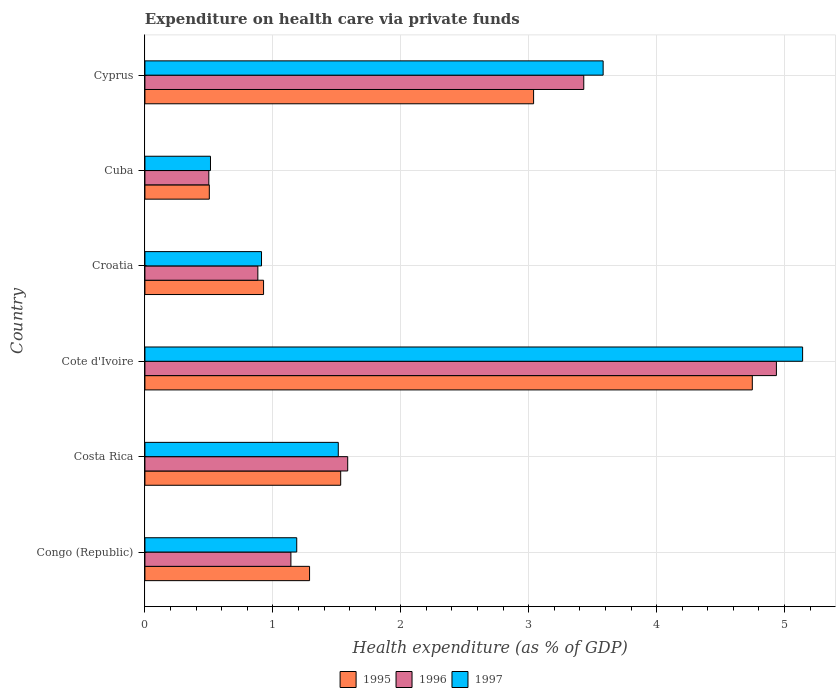How many different coloured bars are there?
Your answer should be very brief. 3. How many groups of bars are there?
Keep it short and to the point. 6. Are the number of bars per tick equal to the number of legend labels?
Your answer should be very brief. Yes. How many bars are there on the 6th tick from the top?
Your response must be concise. 3. What is the label of the 3rd group of bars from the top?
Your answer should be compact. Croatia. What is the expenditure made on health care in 1997 in Croatia?
Offer a terse response. 0.91. Across all countries, what is the maximum expenditure made on health care in 1995?
Your answer should be compact. 4.75. Across all countries, what is the minimum expenditure made on health care in 1996?
Give a very brief answer. 0.5. In which country was the expenditure made on health care in 1996 maximum?
Make the answer very short. Cote d'Ivoire. In which country was the expenditure made on health care in 1997 minimum?
Provide a succinct answer. Cuba. What is the total expenditure made on health care in 1997 in the graph?
Your answer should be very brief. 12.85. What is the difference between the expenditure made on health care in 1996 in Costa Rica and that in Croatia?
Provide a short and direct response. 0.7. What is the difference between the expenditure made on health care in 1997 in Croatia and the expenditure made on health care in 1996 in Congo (Republic)?
Make the answer very short. -0.23. What is the average expenditure made on health care in 1997 per country?
Your response must be concise. 2.14. What is the difference between the expenditure made on health care in 1996 and expenditure made on health care in 1997 in Congo (Republic)?
Your response must be concise. -0.05. In how many countries, is the expenditure made on health care in 1997 greater than 4 %?
Offer a very short reply. 1. What is the ratio of the expenditure made on health care in 1997 in Congo (Republic) to that in Croatia?
Give a very brief answer. 1.3. Is the difference between the expenditure made on health care in 1996 in Congo (Republic) and Croatia greater than the difference between the expenditure made on health care in 1997 in Congo (Republic) and Croatia?
Provide a succinct answer. No. What is the difference between the highest and the second highest expenditure made on health care in 1995?
Your answer should be very brief. 1.71. What is the difference between the highest and the lowest expenditure made on health care in 1996?
Provide a succinct answer. 4.44. What does the 2nd bar from the top in Congo (Republic) represents?
Offer a terse response. 1996. Is it the case that in every country, the sum of the expenditure made on health care in 1995 and expenditure made on health care in 1996 is greater than the expenditure made on health care in 1997?
Make the answer very short. Yes. How many bars are there?
Keep it short and to the point. 18. Are all the bars in the graph horizontal?
Give a very brief answer. Yes. How many countries are there in the graph?
Offer a terse response. 6. Does the graph contain grids?
Your response must be concise. Yes. How many legend labels are there?
Provide a succinct answer. 3. What is the title of the graph?
Provide a short and direct response. Expenditure on health care via private funds. Does "1970" appear as one of the legend labels in the graph?
Your answer should be compact. No. What is the label or title of the X-axis?
Keep it short and to the point. Health expenditure (as % of GDP). What is the Health expenditure (as % of GDP) of 1995 in Congo (Republic)?
Your answer should be compact. 1.29. What is the Health expenditure (as % of GDP) of 1996 in Congo (Republic)?
Your answer should be compact. 1.14. What is the Health expenditure (as % of GDP) in 1997 in Congo (Republic)?
Your response must be concise. 1.19. What is the Health expenditure (as % of GDP) in 1995 in Costa Rica?
Make the answer very short. 1.53. What is the Health expenditure (as % of GDP) in 1996 in Costa Rica?
Provide a succinct answer. 1.59. What is the Health expenditure (as % of GDP) in 1997 in Costa Rica?
Make the answer very short. 1.51. What is the Health expenditure (as % of GDP) of 1995 in Cote d'Ivoire?
Provide a short and direct response. 4.75. What is the Health expenditure (as % of GDP) in 1996 in Cote d'Ivoire?
Offer a very short reply. 4.94. What is the Health expenditure (as % of GDP) in 1997 in Cote d'Ivoire?
Offer a very short reply. 5.14. What is the Health expenditure (as % of GDP) in 1995 in Croatia?
Make the answer very short. 0.93. What is the Health expenditure (as % of GDP) of 1996 in Croatia?
Keep it short and to the point. 0.88. What is the Health expenditure (as % of GDP) in 1997 in Croatia?
Ensure brevity in your answer.  0.91. What is the Health expenditure (as % of GDP) in 1995 in Cuba?
Make the answer very short. 0.5. What is the Health expenditure (as % of GDP) of 1996 in Cuba?
Your response must be concise. 0.5. What is the Health expenditure (as % of GDP) in 1997 in Cuba?
Offer a very short reply. 0.51. What is the Health expenditure (as % of GDP) in 1995 in Cyprus?
Ensure brevity in your answer.  3.04. What is the Health expenditure (as % of GDP) in 1996 in Cyprus?
Make the answer very short. 3.43. What is the Health expenditure (as % of GDP) of 1997 in Cyprus?
Keep it short and to the point. 3.58. Across all countries, what is the maximum Health expenditure (as % of GDP) of 1995?
Offer a very short reply. 4.75. Across all countries, what is the maximum Health expenditure (as % of GDP) of 1996?
Your answer should be very brief. 4.94. Across all countries, what is the maximum Health expenditure (as % of GDP) of 1997?
Your answer should be very brief. 5.14. Across all countries, what is the minimum Health expenditure (as % of GDP) of 1995?
Your answer should be very brief. 0.5. Across all countries, what is the minimum Health expenditure (as % of GDP) in 1996?
Give a very brief answer. 0.5. Across all countries, what is the minimum Health expenditure (as % of GDP) in 1997?
Ensure brevity in your answer.  0.51. What is the total Health expenditure (as % of GDP) of 1995 in the graph?
Your response must be concise. 12.04. What is the total Health expenditure (as % of GDP) of 1996 in the graph?
Provide a succinct answer. 12.48. What is the total Health expenditure (as % of GDP) of 1997 in the graph?
Keep it short and to the point. 12.85. What is the difference between the Health expenditure (as % of GDP) of 1995 in Congo (Republic) and that in Costa Rica?
Keep it short and to the point. -0.24. What is the difference between the Health expenditure (as % of GDP) of 1996 in Congo (Republic) and that in Costa Rica?
Make the answer very short. -0.44. What is the difference between the Health expenditure (as % of GDP) in 1997 in Congo (Republic) and that in Costa Rica?
Your answer should be compact. -0.32. What is the difference between the Health expenditure (as % of GDP) of 1995 in Congo (Republic) and that in Cote d'Ivoire?
Provide a succinct answer. -3.46. What is the difference between the Health expenditure (as % of GDP) in 1996 in Congo (Republic) and that in Cote d'Ivoire?
Your response must be concise. -3.8. What is the difference between the Health expenditure (as % of GDP) of 1997 in Congo (Republic) and that in Cote d'Ivoire?
Your answer should be compact. -3.95. What is the difference between the Health expenditure (as % of GDP) in 1995 in Congo (Republic) and that in Croatia?
Make the answer very short. 0.36. What is the difference between the Health expenditure (as % of GDP) in 1996 in Congo (Republic) and that in Croatia?
Offer a very short reply. 0.26. What is the difference between the Health expenditure (as % of GDP) in 1997 in Congo (Republic) and that in Croatia?
Provide a short and direct response. 0.28. What is the difference between the Health expenditure (as % of GDP) of 1995 in Congo (Republic) and that in Cuba?
Ensure brevity in your answer.  0.78. What is the difference between the Health expenditure (as % of GDP) in 1996 in Congo (Republic) and that in Cuba?
Your answer should be compact. 0.64. What is the difference between the Health expenditure (as % of GDP) in 1997 in Congo (Republic) and that in Cuba?
Give a very brief answer. 0.67. What is the difference between the Health expenditure (as % of GDP) in 1995 in Congo (Republic) and that in Cyprus?
Your response must be concise. -1.75. What is the difference between the Health expenditure (as % of GDP) of 1996 in Congo (Republic) and that in Cyprus?
Make the answer very short. -2.29. What is the difference between the Health expenditure (as % of GDP) of 1997 in Congo (Republic) and that in Cyprus?
Make the answer very short. -2.4. What is the difference between the Health expenditure (as % of GDP) of 1995 in Costa Rica and that in Cote d'Ivoire?
Your response must be concise. -3.22. What is the difference between the Health expenditure (as % of GDP) of 1996 in Costa Rica and that in Cote d'Ivoire?
Provide a short and direct response. -3.35. What is the difference between the Health expenditure (as % of GDP) of 1997 in Costa Rica and that in Cote d'Ivoire?
Your response must be concise. -3.63. What is the difference between the Health expenditure (as % of GDP) in 1995 in Costa Rica and that in Croatia?
Give a very brief answer. 0.6. What is the difference between the Health expenditure (as % of GDP) in 1996 in Costa Rica and that in Croatia?
Keep it short and to the point. 0.7. What is the difference between the Health expenditure (as % of GDP) of 1997 in Costa Rica and that in Croatia?
Keep it short and to the point. 0.6. What is the difference between the Health expenditure (as % of GDP) in 1995 in Costa Rica and that in Cuba?
Your answer should be compact. 1.03. What is the difference between the Health expenditure (as % of GDP) in 1996 in Costa Rica and that in Cuba?
Provide a short and direct response. 1.09. What is the difference between the Health expenditure (as % of GDP) of 1997 in Costa Rica and that in Cuba?
Keep it short and to the point. 1. What is the difference between the Health expenditure (as % of GDP) in 1995 in Costa Rica and that in Cyprus?
Provide a short and direct response. -1.51. What is the difference between the Health expenditure (as % of GDP) of 1996 in Costa Rica and that in Cyprus?
Your answer should be very brief. -1.85. What is the difference between the Health expenditure (as % of GDP) of 1997 in Costa Rica and that in Cyprus?
Your response must be concise. -2.07. What is the difference between the Health expenditure (as % of GDP) of 1995 in Cote d'Ivoire and that in Croatia?
Your answer should be very brief. 3.82. What is the difference between the Health expenditure (as % of GDP) in 1996 in Cote d'Ivoire and that in Croatia?
Your answer should be compact. 4.05. What is the difference between the Health expenditure (as % of GDP) of 1997 in Cote d'Ivoire and that in Croatia?
Make the answer very short. 4.23. What is the difference between the Health expenditure (as % of GDP) in 1995 in Cote d'Ivoire and that in Cuba?
Your answer should be compact. 4.24. What is the difference between the Health expenditure (as % of GDP) in 1996 in Cote d'Ivoire and that in Cuba?
Your response must be concise. 4.44. What is the difference between the Health expenditure (as % of GDP) in 1997 in Cote d'Ivoire and that in Cuba?
Provide a succinct answer. 4.63. What is the difference between the Health expenditure (as % of GDP) in 1995 in Cote d'Ivoire and that in Cyprus?
Your response must be concise. 1.71. What is the difference between the Health expenditure (as % of GDP) of 1996 in Cote d'Ivoire and that in Cyprus?
Your answer should be compact. 1.51. What is the difference between the Health expenditure (as % of GDP) in 1997 in Cote d'Ivoire and that in Cyprus?
Provide a short and direct response. 1.56. What is the difference between the Health expenditure (as % of GDP) in 1995 in Croatia and that in Cuba?
Your answer should be compact. 0.42. What is the difference between the Health expenditure (as % of GDP) of 1996 in Croatia and that in Cuba?
Give a very brief answer. 0.38. What is the difference between the Health expenditure (as % of GDP) in 1997 in Croatia and that in Cuba?
Your response must be concise. 0.4. What is the difference between the Health expenditure (as % of GDP) in 1995 in Croatia and that in Cyprus?
Make the answer very short. -2.11. What is the difference between the Health expenditure (as % of GDP) in 1996 in Croatia and that in Cyprus?
Provide a succinct answer. -2.55. What is the difference between the Health expenditure (as % of GDP) in 1997 in Croatia and that in Cyprus?
Provide a succinct answer. -2.67. What is the difference between the Health expenditure (as % of GDP) of 1995 in Cuba and that in Cyprus?
Make the answer very short. -2.54. What is the difference between the Health expenditure (as % of GDP) in 1996 in Cuba and that in Cyprus?
Keep it short and to the point. -2.93. What is the difference between the Health expenditure (as % of GDP) of 1997 in Cuba and that in Cyprus?
Provide a succinct answer. -3.07. What is the difference between the Health expenditure (as % of GDP) of 1995 in Congo (Republic) and the Health expenditure (as % of GDP) of 1996 in Costa Rica?
Make the answer very short. -0.3. What is the difference between the Health expenditure (as % of GDP) in 1995 in Congo (Republic) and the Health expenditure (as % of GDP) in 1997 in Costa Rica?
Your answer should be compact. -0.22. What is the difference between the Health expenditure (as % of GDP) in 1996 in Congo (Republic) and the Health expenditure (as % of GDP) in 1997 in Costa Rica?
Offer a terse response. -0.37. What is the difference between the Health expenditure (as % of GDP) of 1995 in Congo (Republic) and the Health expenditure (as % of GDP) of 1996 in Cote d'Ivoire?
Your response must be concise. -3.65. What is the difference between the Health expenditure (as % of GDP) of 1995 in Congo (Republic) and the Health expenditure (as % of GDP) of 1997 in Cote d'Ivoire?
Make the answer very short. -3.85. What is the difference between the Health expenditure (as % of GDP) of 1996 in Congo (Republic) and the Health expenditure (as % of GDP) of 1997 in Cote d'Ivoire?
Give a very brief answer. -4. What is the difference between the Health expenditure (as % of GDP) in 1995 in Congo (Republic) and the Health expenditure (as % of GDP) in 1996 in Croatia?
Your response must be concise. 0.4. What is the difference between the Health expenditure (as % of GDP) in 1995 in Congo (Republic) and the Health expenditure (as % of GDP) in 1997 in Croatia?
Provide a succinct answer. 0.38. What is the difference between the Health expenditure (as % of GDP) in 1996 in Congo (Republic) and the Health expenditure (as % of GDP) in 1997 in Croatia?
Ensure brevity in your answer.  0.23. What is the difference between the Health expenditure (as % of GDP) in 1995 in Congo (Republic) and the Health expenditure (as % of GDP) in 1996 in Cuba?
Provide a succinct answer. 0.79. What is the difference between the Health expenditure (as % of GDP) of 1995 in Congo (Republic) and the Health expenditure (as % of GDP) of 1997 in Cuba?
Keep it short and to the point. 0.77. What is the difference between the Health expenditure (as % of GDP) of 1996 in Congo (Republic) and the Health expenditure (as % of GDP) of 1997 in Cuba?
Offer a very short reply. 0.63. What is the difference between the Health expenditure (as % of GDP) in 1995 in Congo (Republic) and the Health expenditure (as % of GDP) in 1996 in Cyprus?
Make the answer very short. -2.14. What is the difference between the Health expenditure (as % of GDP) in 1995 in Congo (Republic) and the Health expenditure (as % of GDP) in 1997 in Cyprus?
Provide a short and direct response. -2.29. What is the difference between the Health expenditure (as % of GDP) in 1996 in Congo (Republic) and the Health expenditure (as % of GDP) in 1997 in Cyprus?
Your answer should be very brief. -2.44. What is the difference between the Health expenditure (as % of GDP) of 1995 in Costa Rica and the Health expenditure (as % of GDP) of 1996 in Cote d'Ivoire?
Offer a terse response. -3.41. What is the difference between the Health expenditure (as % of GDP) of 1995 in Costa Rica and the Health expenditure (as % of GDP) of 1997 in Cote d'Ivoire?
Your answer should be very brief. -3.61. What is the difference between the Health expenditure (as % of GDP) of 1996 in Costa Rica and the Health expenditure (as % of GDP) of 1997 in Cote d'Ivoire?
Your response must be concise. -3.56. What is the difference between the Health expenditure (as % of GDP) in 1995 in Costa Rica and the Health expenditure (as % of GDP) in 1996 in Croatia?
Your answer should be compact. 0.65. What is the difference between the Health expenditure (as % of GDP) in 1995 in Costa Rica and the Health expenditure (as % of GDP) in 1997 in Croatia?
Provide a short and direct response. 0.62. What is the difference between the Health expenditure (as % of GDP) of 1996 in Costa Rica and the Health expenditure (as % of GDP) of 1997 in Croatia?
Keep it short and to the point. 0.67. What is the difference between the Health expenditure (as % of GDP) of 1995 in Costa Rica and the Health expenditure (as % of GDP) of 1996 in Cuba?
Your answer should be compact. 1.03. What is the difference between the Health expenditure (as % of GDP) of 1995 in Costa Rica and the Health expenditure (as % of GDP) of 1997 in Cuba?
Offer a terse response. 1.02. What is the difference between the Health expenditure (as % of GDP) in 1996 in Costa Rica and the Health expenditure (as % of GDP) in 1997 in Cuba?
Ensure brevity in your answer.  1.07. What is the difference between the Health expenditure (as % of GDP) of 1995 in Costa Rica and the Health expenditure (as % of GDP) of 1996 in Cyprus?
Give a very brief answer. -1.9. What is the difference between the Health expenditure (as % of GDP) in 1995 in Costa Rica and the Health expenditure (as % of GDP) in 1997 in Cyprus?
Provide a succinct answer. -2.05. What is the difference between the Health expenditure (as % of GDP) of 1996 in Costa Rica and the Health expenditure (as % of GDP) of 1997 in Cyprus?
Keep it short and to the point. -2. What is the difference between the Health expenditure (as % of GDP) in 1995 in Cote d'Ivoire and the Health expenditure (as % of GDP) in 1996 in Croatia?
Keep it short and to the point. 3.87. What is the difference between the Health expenditure (as % of GDP) in 1995 in Cote d'Ivoire and the Health expenditure (as % of GDP) in 1997 in Croatia?
Ensure brevity in your answer.  3.84. What is the difference between the Health expenditure (as % of GDP) in 1996 in Cote d'Ivoire and the Health expenditure (as % of GDP) in 1997 in Croatia?
Give a very brief answer. 4.03. What is the difference between the Health expenditure (as % of GDP) of 1995 in Cote d'Ivoire and the Health expenditure (as % of GDP) of 1996 in Cuba?
Ensure brevity in your answer.  4.25. What is the difference between the Health expenditure (as % of GDP) in 1995 in Cote d'Ivoire and the Health expenditure (as % of GDP) in 1997 in Cuba?
Give a very brief answer. 4.24. What is the difference between the Health expenditure (as % of GDP) in 1996 in Cote d'Ivoire and the Health expenditure (as % of GDP) in 1997 in Cuba?
Offer a terse response. 4.42. What is the difference between the Health expenditure (as % of GDP) in 1995 in Cote d'Ivoire and the Health expenditure (as % of GDP) in 1996 in Cyprus?
Your answer should be very brief. 1.32. What is the difference between the Health expenditure (as % of GDP) in 1995 in Cote d'Ivoire and the Health expenditure (as % of GDP) in 1997 in Cyprus?
Offer a very short reply. 1.17. What is the difference between the Health expenditure (as % of GDP) of 1996 in Cote d'Ivoire and the Health expenditure (as % of GDP) of 1997 in Cyprus?
Your answer should be compact. 1.35. What is the difference between the Health expenditure (as % of GDP) of 1995 in Croatia and the Health expenditure (as % of GDP) of 1996 in Cuba?
Provide a short and direct response. 0.43. What is the difference between the Health expenditure (as % of GDP) in 1995 in Croatia and the Health expenditure (as % of GDP) in 1997 in Cuba?
Give a very brief answer. 0.41. What is the difference between the Health expenditure (as % of GDP) of 1996 in Croatia and the Health expenditure (as % of GDP) of 1997 in Cuba?
Offer a very short reply. 0.37. What is the difference between the Health expenditure (as % of GDP) of 1995 in Croatia and the Health expenditure (as % of GDP) of 1996 in Cyprus?
Your answer should be compact. -2.5. What is the difference between the Health expenditure (as % of GDP) of 1995 in Croatia and the Health expenditure (as % of GDP) of 1997 in Cyprus?
Give a very brief answer. -2.65. What is the difference between the Health expenditure (as % of GDP) of 1996 in Croatia and the Health expenditure (as % of GDP) of 1997 in Cyprus?
Your answer should be compact. -2.7. What is the difference between the Health expenditure (as % of GDP) of 1995 in Cuba and the Health expenditure (as % of GDP) of 1996 in Cyprus?
Your answer should be compact. -2.93. What is the difference between the Health expenditure (as % of GDP) of 1995 in Cuba and the Health expenditure (as % of GDP) of 1997 in Cyprus?
Ensure brevity in your answer.  -3.08. What is the difference between the Health expenditure (as % of GDP) in 1996 in Cuba and the Health expenditure (as % of GDP) in 1997 in Cyprus?
Your response must be concise. -3.08. What is the average Health expenditure (as % of GDP) in 1995 per country?
Give a very brief answer. 2.01. What is the average Health expenditure (as % of GDP) in 1996 per country?
Your response must be concise. 2.08. What is the average Health expenditure (as % of GDP) in 1997 per country?
Your response must be concise. 2.14. What is the difference between the Health expenditure (as % of GDP) of 1995 and Health expenditure (as % of GDP) of 1996 in Congo (Republic)?
Your answer should be very brief. 0.15. What is the difference between the Health expenditure (as % of GDP) in 1995 and Health expenditure (as % of GDP) in 1997 in Congo (Republic)?
Offer a very short reply. 0.1. What is the difference between the Health expenditure (as % of GDP) of 1996 and Health expenditure (as % of GDP) of 1997 in Congo (Republic)?
Give a very brief answer. -0.05. What is the difference between the Health expenditure (as % of GDP) of 1995 and Health expenditure (as % of GDP) of 1996 in Costa Rica?
Give a very brief answer. -0.05. What is the difference between the Health expenditure (as % of GDP) of 1995 and Health expenditure (as % of GDP) of 1997 in Costa Rica?
Offer a very short reply. 0.02. What is the difference between the Health expenditure (as % of GDP) of 1996 and Health expenditure (as % of GDP) of 1997 in Costa Rica?
Provide a short and direct response. 0.07. What is the difference between the Health expenditure (as % of GDP) of 1995 and Health expenditure (as % of GDP) of 1996 in Cote d'Ivoire?
Provide a short and direct response. -0.19. What is the difference between the Health expenditure (as % of GDP) of 1995 and Health expenditure (as % of GDP) of 1997 in Cote d'Ivoire?
Give a very brief answer. -0.39. What is the difference between the Health expenditure (as % of GDP) in 1996 and Health expenditure (as % of GDP) in 1997 in Cote d'Ivoire?
Keep it short and to the point. -0.2. What is the difference between the Health expenditure (as % of GDP) in 1995 and Health expenditure (as % of GDP) in 1996 in Croatia?
Your answer should be compact. 0.04. What is the difference between the Health expenditure (as % of GDP) in 1995 and Health expenditure (as % of GDP) in 1997 in Croatia?
Provide a succinct answer. 0.02. What is the difference between the Health expenditure (as % of GDP) of 1996 and Health expenditure (as % of GDP) of 1997 in Croatia?
Make the answer very short. -0.03. What is the difference between the Health expenditure (as % of GDP) in 1995 and Health expenditure (as % of GDP) in 1996 in Cuba?
Keep it short and to the point. 0. What is the difference between the Health expenditure (as % of GDP) in 1995 and Health expenditure (as % of GDP) in 1997 in Cuba?
Provide a short and direct response. -0.01. What is the difference between the Health expenditure (as % of GDP) in 1996 and Health expenditure (as % of GDP) in 1997 in Cuba?
Your answer should be very brief. -0.01. What is the difference between the Health expenditure (as % of GDP) of 1995 and Health expenditure (as % of GDP) of 1996 in Cyprus?
Your response must be concise. -0.39. What is the difference between the Health expenditure (as % of GDP) in 1995 and Health expenditure (as % of GDP) in 1997 in Cyprus?
Your response must be concise. -0.54. What is the difference between the Health expenditure (as % of GDP) in 1996 and Health expenditure (as % of GDP) in 1997 in Cyprus?
Offer a very short reply. -0.15. What is the ratio of the Health expenditure (as % of GDP) in 1995 in Congo (Republic) to that in Costa Rica?
Keep it short and to the point. 0.84. What is the ratio of the Health expenditure (as % of GDP) in 1996 in Congo (Republic) to that in Costa Rica?
Keep it short and to the point. 0.72. What is the ratio of the Health expenditure (as % of GDP) in 1997 in Congo (Republic) to that in Costa Rica?
Provide a short and direct response. 0.79. What is the ratio of the Health expenditure (as % of GDP) of 1995 in Congo (Republic) to that in Cote d'Ivoire?
Make the answer very short. 0.27. What is the ratio of the Health expenditure (as % of GDP) in 1996 in Congo (Republic) to that in Cote d'Ivoire?
Provide a short and direct response. 0.23. What is the ratio of the Health expenditure (as % of GDP) of 1997 in Congo (Republic) to that in Cote d'Ivoire?
Offer a very short reply. 0.23. What is the ratio of the Health expenditure (as % of GDP) in 1995 in Congo (Republic) to that in Croatia?
Your answer should be compact. 1.39. What is the ratio of the Health expenditure (as % of GDP) in 1996 in Congo (Republic) to that in Croatia?
Ensure brevity in your answer.  1.29. What is the ratio of the Health expenditure (as % of GDP) in 1997 in Congo (Republic) to that in Croatia?
Make the answer very short. 1.3. What is the ratio of the Health expenditure (as % of GDP) in 1995 in Congo (Republic) to that in Cuba?
Provide a short and direct response. 2.56. What is the ratio of the Health expenditure (as % of GDP) of 1996 in Congo (Republic) to that in Cuba?
Your answer should be compact. 2.28. What is the ratio of the Health expenditure (as % of GDP) of 1997 in Congo (Republic) to that in Cuba?
Offer a terse response. 2.32. What is the ratio of the Health expenditure (as % of GDP) of 1995 in Congo (Republic) to that in Cyprus?
Your answer should be very brief. 0.42. What is the ratio of the Health expenditure (as % of GDP) of 1996 in Congo (Republic) to that in Cyprus?
Keep it short and to the point. 0.33. What is the ratio of the Health expenditure (as % of GDP) in 1997 in Congo (Republic) to that in Cyprus?
Offer a terse response. 0.33. What is the ratio of the Health expenditure (as % of GDP) of 1995 in Costa Rica to that in Cote d'Ivoire?
Make the answer very short. 0.32. What is the ratio of the Health expenditure (as % of GDP) of 1996 in Costa Rica to that in Cote d'Ivoire?
Your answer should be compact. 0.32. What is the ratio of the Health expenditure (as % of GDP) of 1997 in Costa Rica to that in Cote d'Ivoire?
Make the answer very short. 0.29. What is the ratio of the Health expenditure (as % of GDP) in 1995 in Costa Rica to that in Croatia?
Your answer should be very brief. 1.65. What is the ratio of the Health expenditure (as % of GDP) of 1996 in Costa Rica to that in Croatia?
Make the answer very short. 1.8. What is the ratio of the Health expenditure (as % of GDP) in 1997 in Costa Rica to that in Croatia?
Give a very brief answer. 1.66. What is the ratio of the Health expenditure (as % of GDP) in 1995 in Costa Rica to that in Cuba?
Make the answer very short. 3.04. What is the ratio of the Health expenditure (as % of GDP) in 1996 in Costa Rica to that in Cuba?
Your answer should be very brief. 3.17. What is the ratio of the Health expenditure (as % of GDP) of 1997 in Costa Rica to that in Cuba?
Offer a terse response. 2.95. What is the ratio of the Health expenditure (as % of GDP) of 1995 in Costa Rica to that in Cyprus?
Keep it short and to the point. 0.5. What is the ratio of the Health expenditure (as % of GDP) of 1996 in Costa Rica to that in Cyprus?
Provide a short and direct response. 0.46. What is the ratio of the Health expenditure (as % of GDP) of 1997 in Costa Rica to that in Cyprus?
Offer a very short reply. 0.42. What is the ratio of the Health expenditure (as % of GDP) of 1995 in Cote d'Ivoire to that in Croatia?
Keep it short and to the point. 5.12. What is the ratio of the Health expenditure (as % of GDP) in 1996 in Cote d'Ivoire to that in Croatia?
Your response must be concise. 5.59. What is the ratio of the Health expenditure (as % of GDP) of 1997 in Cote d'Ivoire to that in Croatia?
Your answer should be compact. 5.64. What is the ratio of the Health expenditure (as % of GDP) of 1995 in Cote d'Ivoire to that in Cuba?
Provide a succinct answer. 9.43. What is the ratio of the Health expenditure (as % of GDP) in 1996 in Cote d'Ivoire to that in Cuba?
Your response must be concise. 9.88. What is the ratio of the Health expenditure (as % of GDP) in 1997 in Cote d'Ivoire to that in Cuba?
Ensure brevity in your answer.  10.03. What is the ratio of the Health expenditure (as % of GDP) in 1995 in Cote d'Ivoire to that in Cyprus?
Your answer should be very brief. 1.56. What is the ratio of the Health expenditure (as % of GDP) in 1996 in Cote d'Ivoire to that in Cyprus?
Offer a terse response. 1.44. What is the ratio of the Health expenditure (as % of GDP) in 1997 in Cote d'Ivoire to that in Cyprus?
Offer a very short reply. 1.44. What is the ratio of the Health expenditure (as % of GDP) in 1995 in Croatia to that in Cuba?
Provide a succinct answer. 1.84. What is the ratio of the Health expenditure (as % of GDP) of 1996 in Croatia to that in Cuba?
Make the answer very short. 1.77. What is the ratio of the Health expenditure (as % of GDP) in 1997 in Croatia to that in Cuba?
Your answer should be compact. 1.78. What is the ratio of the Health expenditure (as % of GDP) of 1995 in Croatia to that in Cyprus?
Provide a short and direct response. 0.31. What is the ratio of the Health expenditure (as % of GDP) in 1996 in Croatia to that in Cyprus?
Make the answer very short. 0.26. What is the ratio of the Health expenditure (as % of GDP) of 1997 in Croatia to that in Cyprus?
Offer a very short reply. 0.25. What is the ratio of the Health expenditure (as % of GDP) in 1995 in Cuba to that in Cyprus?
Make the answer very short. 0.17. What is the ratio of the Health expenditure (as % of GDP) in 1996 in Cuba to that in Cyprus?
Your response must be concise. 0.15. What is the ratio of the Health expenditure (as % of GDP) in 1997 in Cuba to that in Cyprus?
Ensure brevity in your answer.  0.14. What is the difference between the highest and the second highest Health expenditure (as % of GDP) in 1995?
Provide a succinct answer. 1.71. What is the difference between the highest and the second highest Health expenditure (as % of GDP) in 1996?
Provide a succinct answer. 1.51. What is the difference between the highest and the second highest Health expenditure (as % of GDP) in 1997?
Your response must be concise. 1.56. What is the difference between the highest and the lowest Health expenditure (as % of GDP) in 1995?
Your answer should be very brief. 4.24. What is the difference between the highest and the lowest Health expenditure (as % of GDP) of 1996?
Your answer should be compact. 4.44. What is the difference between the highest and the lowest Health expenditure (as % of GDP) in 1997?
Offer a terse response. 4.63. 